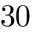Convert formula to latex. <formula><loc_0><loc_0><loc_500><loc_500>3 0</formula> 